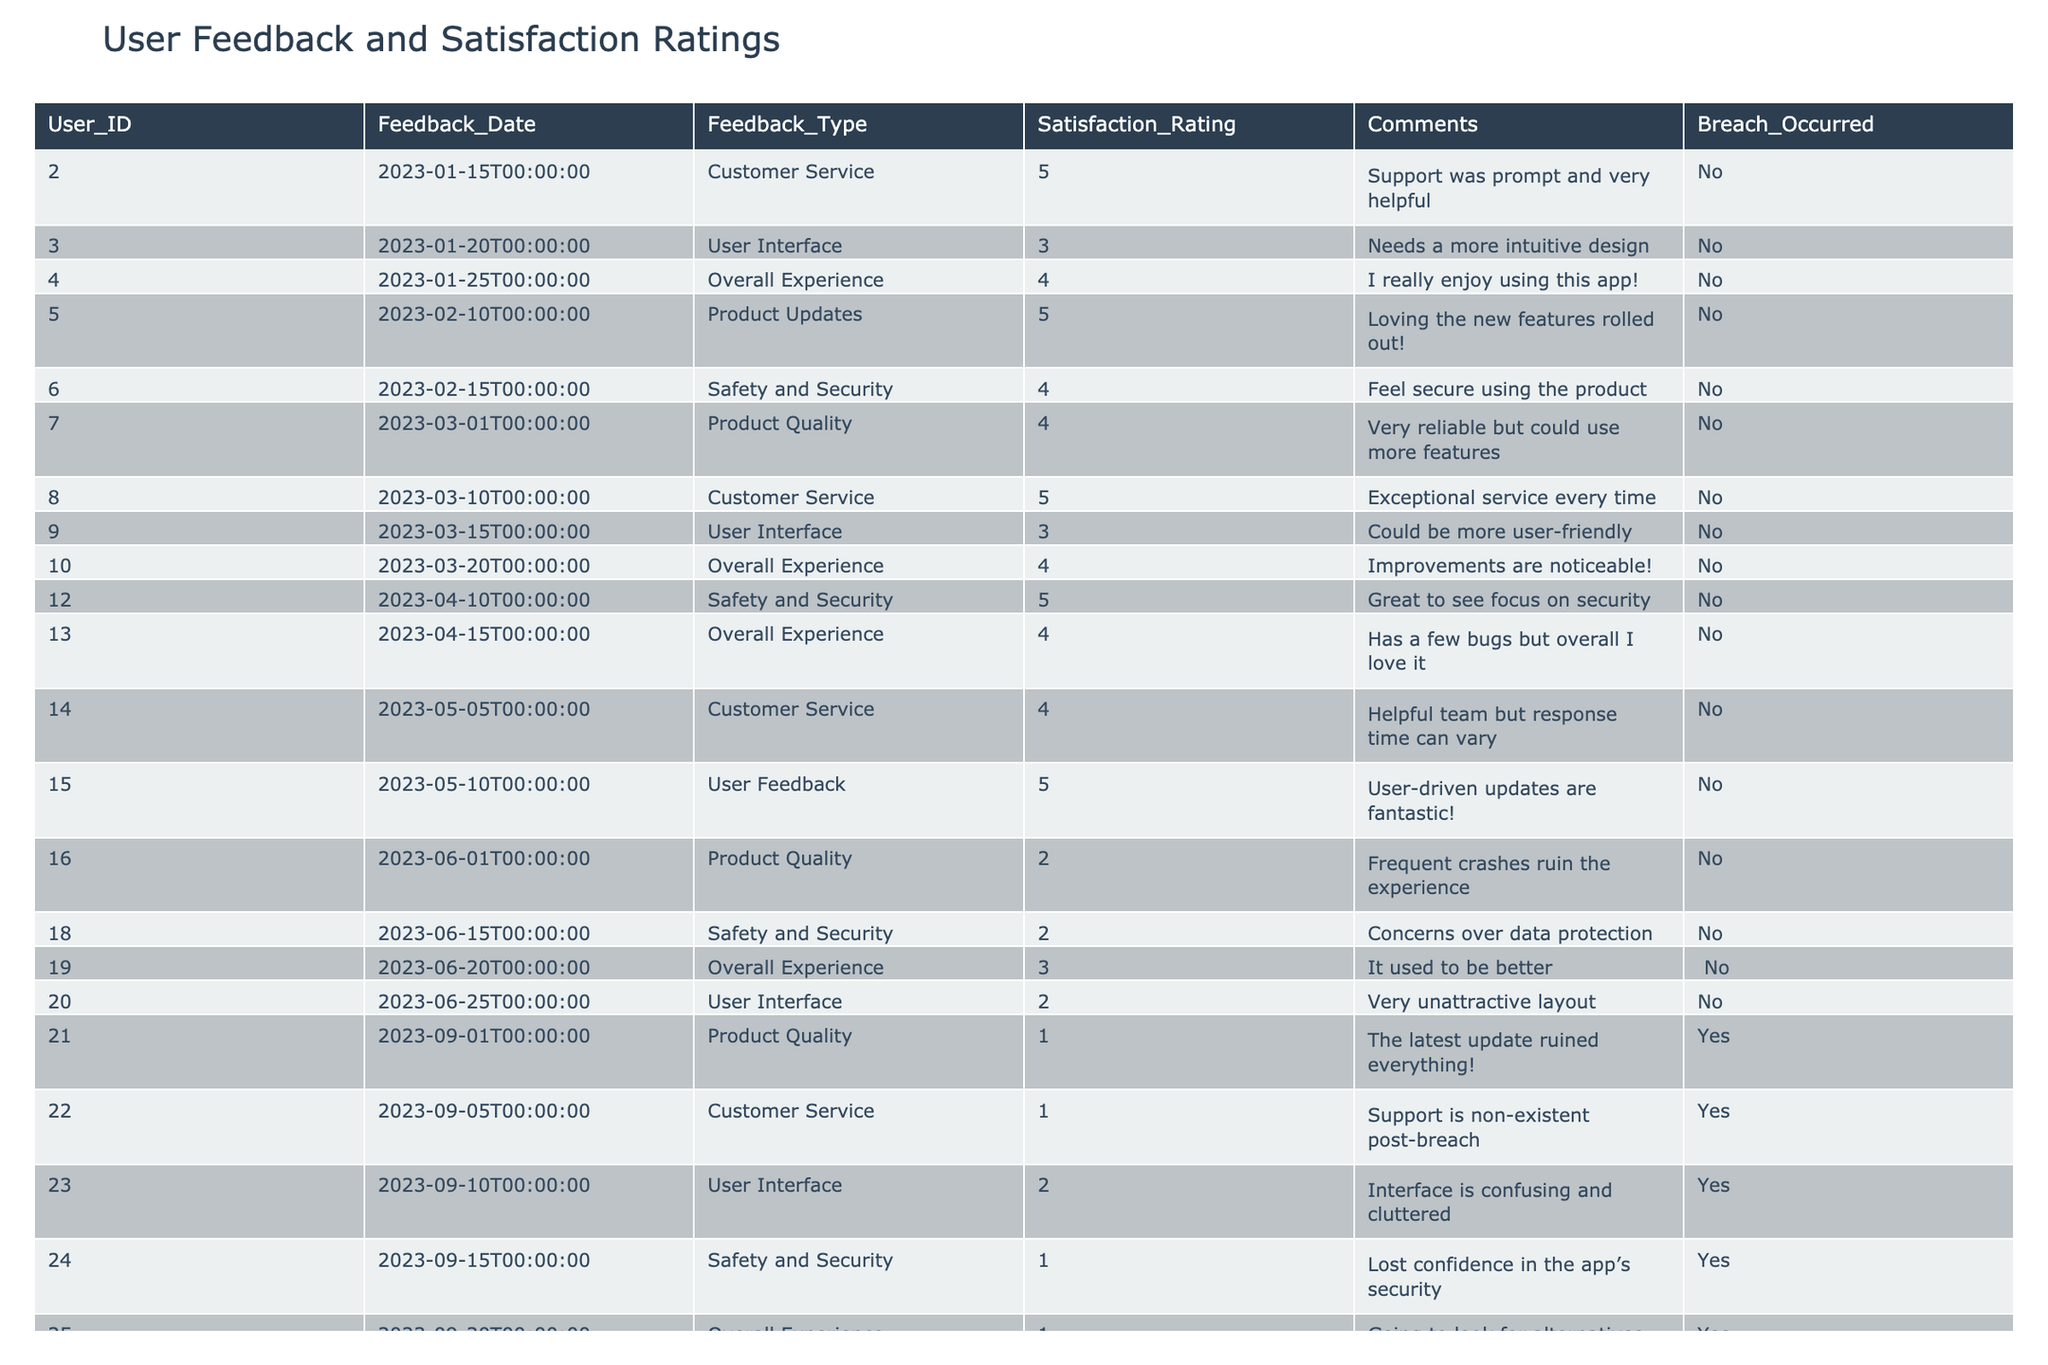What is the highest satisfaction rating before the breach? Looking at the table, the highest satisfaction rating before the breach is 5, with entries on 2023-01-15, 2023-02-10, and 2023-04-12.
Answer: 5 What feedback type had the lowest satisfaction rating after the breach? In the table, the lowest satisfaction rating after the breach is 1, specifically for "Product Quality," "Customer Service," "User Interface," and "Safety and Security."
Answer: Product Quality, Customer Service, User Interface, Safety and Security What was the overall experience rating before the breach? From the table, the ratings for "Overall Experience" before the breach are 4, 4, and 3, leading to a mean value of (4 + 4 + 3) / 3 = 3.67.
Answer: 3.67 Is there any user feedback indicating a decrease in satisfaction related to safety after the breach? Yes, "Safety and Security" had a rating of 4 before the breach and dropped to 1 afterwards, showing a significant decrease.
Answer: Yes What is the average satisfaction rating for customer service before and after the breach? The ratings before the breach are 5, 5, 4; the total is 14, the average is 14/3 = 4.67. After the breach, the rating dropped to 1 and 2, total 3; the average after is 3/2 = 1.5. Thus, the averages are 4.67 before and 1.5 after.
Answer: 4.67 before, 1.5 after How many feedback entries were received after the breach? There are 9 entries listed after the breach occurred, as identified by the "Yes" value in the "Breach_Occurred" column.
Answer: 9 What trends can be observed regarding user interface ratings before and after the breach? Before the breach, user interface ratings were 3, 2, and 4, which averaged to (3 + 2 + 4) / 3 = 3. After the breach, the ratings dropped to 2 and 2, averaging (2 + 2) / 2 = 2. The trend shows a decrease from approx. 3 to 2.
Answer: Decreased from approx. 3 to 2 Which feedback type retained a satisfaction rating of 3 after the breach? According to the table, "Product Feedback" rated a 3 after the breach, indicating it retained this level of satisfaction.
Answer: Product Feedback 